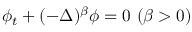<formula> <loc_0><loc_0><loc_500><loc_500>\phi _ { t } + ( - \Delta ) ^ { \beta } \phi = 0 \ ( \beta > 0 )</formula> 